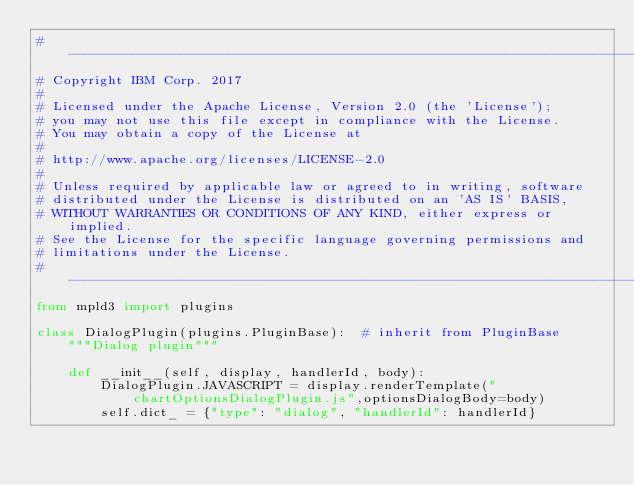Convert code to text. <code><loc_0><loc_0><loc_500><loc_500><_Python_># -------------------------------------------------------------------------------
# Copyright IBM Corp. 2017
# 
# Licensed under the Apache License, Version 2.0 (the 'License');
# you may not use this file except in compliance with the License.
# You may obtain a copy of the License at
# 
# http://www.apache.org/licenses/LICENSE-2.0
# 
# Unless required by applicable law or agreed to in writing, software
# distributed under the License is distributed on an 'AS IS' BASIS,
# WITHOUT WARRANTIES OR CONDITIONS OF ANY KIND, either express or implied.
# See the License for the specific language governing permissions and
# limitations under the License.
# -------------------------------------------------------------------------------
from mpld3 import plugins

class DialogPlugin(plugins.PluginBase):  # inherit from PluginBase
    """Dialog plugin"""
    
    def __init__(self, display, handlerId, body):
        DialogPlugin.JAVASCRIPT = display.renderTemplate("chartOptionsDialogPlugin.js",optionsDialogBody=body)
        self.dict_ = {"type": "dialog", "handlerId": handlerId}</code> 